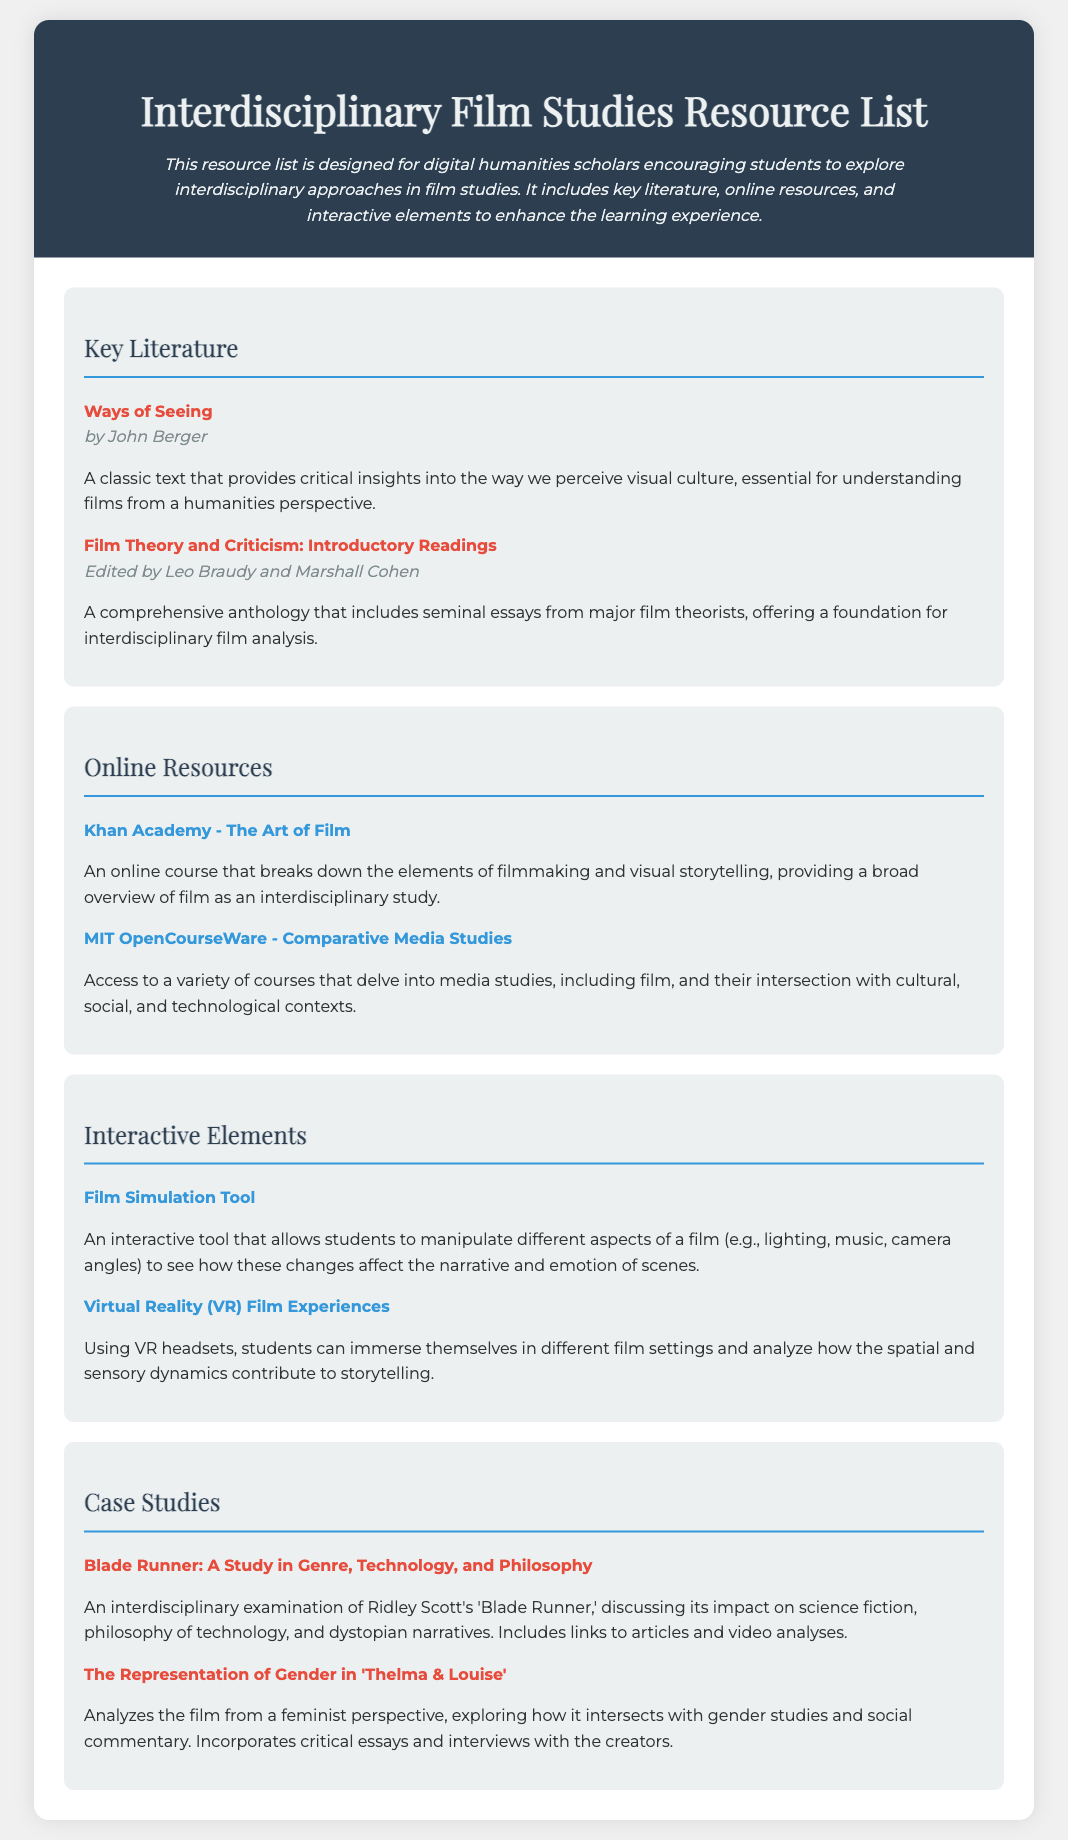What is the title of the document? The title of the document is presented in the header and prominently displayed.
Answer: Interdisciplinary Film Studies Resource List Who is the author of "Ways of Seeing"? The author is identified immediately after the title in the list of key literature.
Answer: John Berger How many sections are there in the document? The number of sections is determined by counting the different categorized lists provided.
Answer: Four What online resource includes a course on filmmaking? The online resources section lists various resources, and this specific one is mentioned alongside its description.
Answer: Khan Academy - The Art of Film Which film is analyzed from a feminist perspective? The title is mentioned in the case studies section which explores different themes.
Answer: Thelma & Louise What is the purpose of the Film Simulation Tool? The tool's purpose is described in the section detailing interactive elements.
Answer: To manipulate aspects of a film Who are the editors of "Film Theory and Criticism: Introductory Readings"? The editors are noted right after the title in the key literature section.
Answer: Leo Braudy and Marshall Cohen What type of experiences does the last interactive element provide? The last interactive element's description clarifies the nature of experiences it offers.
Answer: Virtual Reality (VR) Film Experiences What is the main theme of the case study on "Blade Runner"? The theme is articulated in the description of the case study, summarizing its interdisciplinary focus.
Answer: Genre, Technology, and Philosophy 